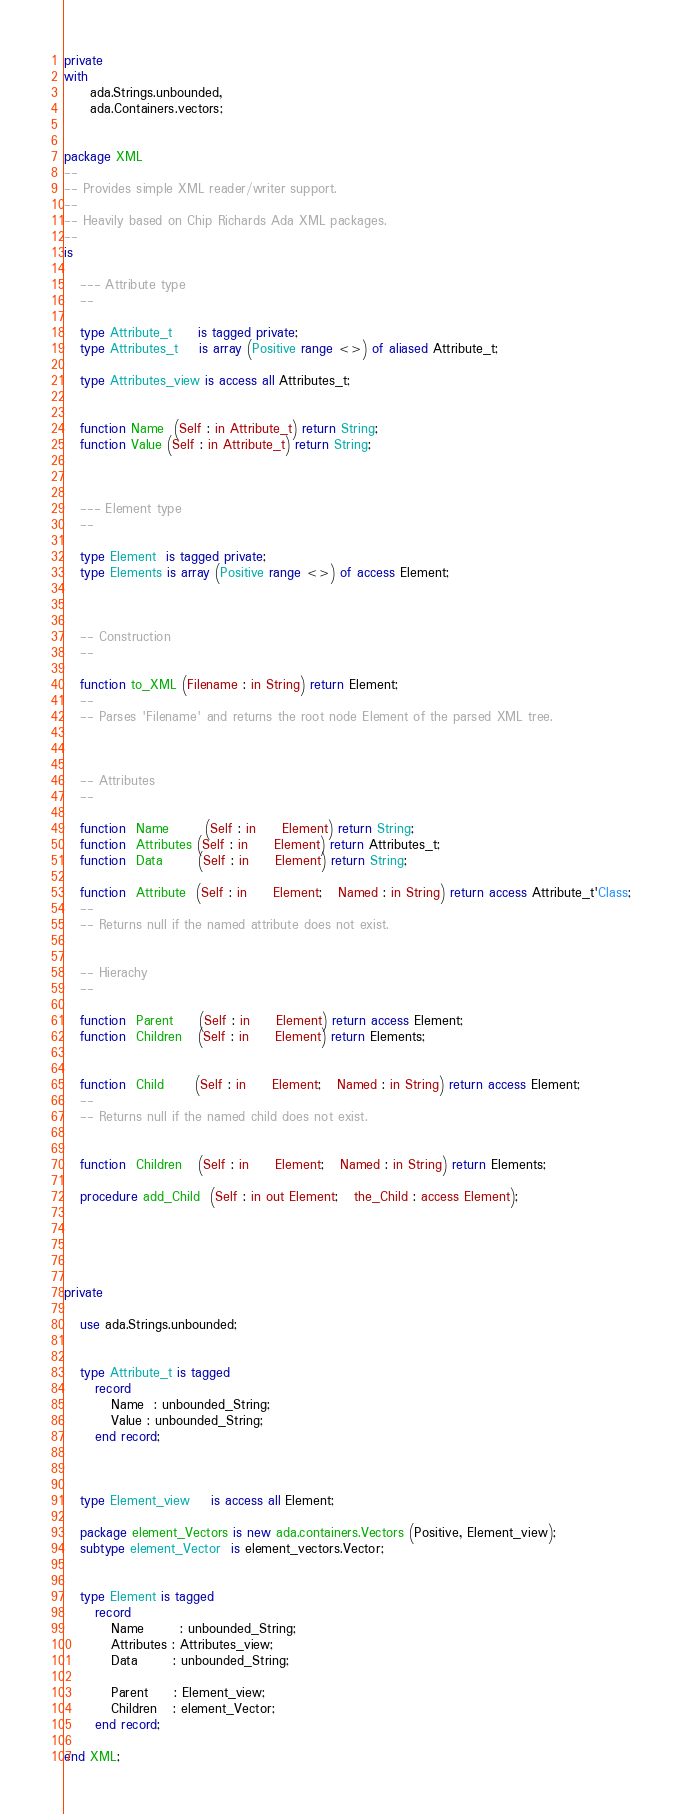Convert code to text. <code><loc_0><loc_0><loc_500><loc_500><_Ada_>private
with
     ada.Strings.unbounded,
     ada.Containers.vectors;


package XML
--
-- Provides simple XML reader/writer support.
--
-- Heavily based on Chip Richards Ada XML packages.
--
is

   --- Attribute type
   --

   type Attribute_t     is tagged private;
   type Attributes_t    is array (Positive range <>) of aliased Attribute_t;

   type Attributes_view is access all Attributes_t;


   function Name  (Self : in Attribute_t) return String;
   function Value (Self : in Attribute_t) return String;



   --- Element type
   --

   type Element  is tagged private;
   type Elements is array (Positive range <>) of access Element;



   -- Construction
   --

   function to_XML (Filename : in String) return Element;
   --
   -- Parses 'Filename' and returns the root node Element of the parsed XML tree.



   -- Attributes
   --

   function  Name       (Self : in     Element) return String;
   function  Attributes (Self : in     Element) return Attributes_t;
   function  Data       (Self : in     Element) return String;

   function  Attribute  (Self : in     Element;   Named : in String) return access Attribute_t'Class;
   --
   -- Returns null if the named attribute does not exist.


   -- Hierachy
   --

   function  Parent     (Self : in     Element) return access Element;
   function  Children   (Self : in     Element) return Elements;


   function  Child      (Self : in     Element;   Named : in String) return access Element;
   --
   -- Returns null if the named child does not exist.


   function  Children   (Self : in     Element;   Named : in String) return Elements;

   procedure add_Child  (Self : in out Element;   the_Child : access Element);





private

   use ada.Strings.unbounded;


   type Attribute_t is tagged
      record
         Name  : unbounded_String;
         Value : unbounded_String;
      end record;



   type Element_view    is access all Element;

   package element_Vectors is new ada.containers.Vectors (Positive, Element_view);
   subtype element_Vector  is element_vectors.Vector;


   type Element is tagged
      record
         Name       : unbounded_String;
         Attributes : Attributes_view;
         Data       : unbounded_String;

         Parent     : Element_view;
         Children   : element_Vector;
      end record;

end XML;
</code> 